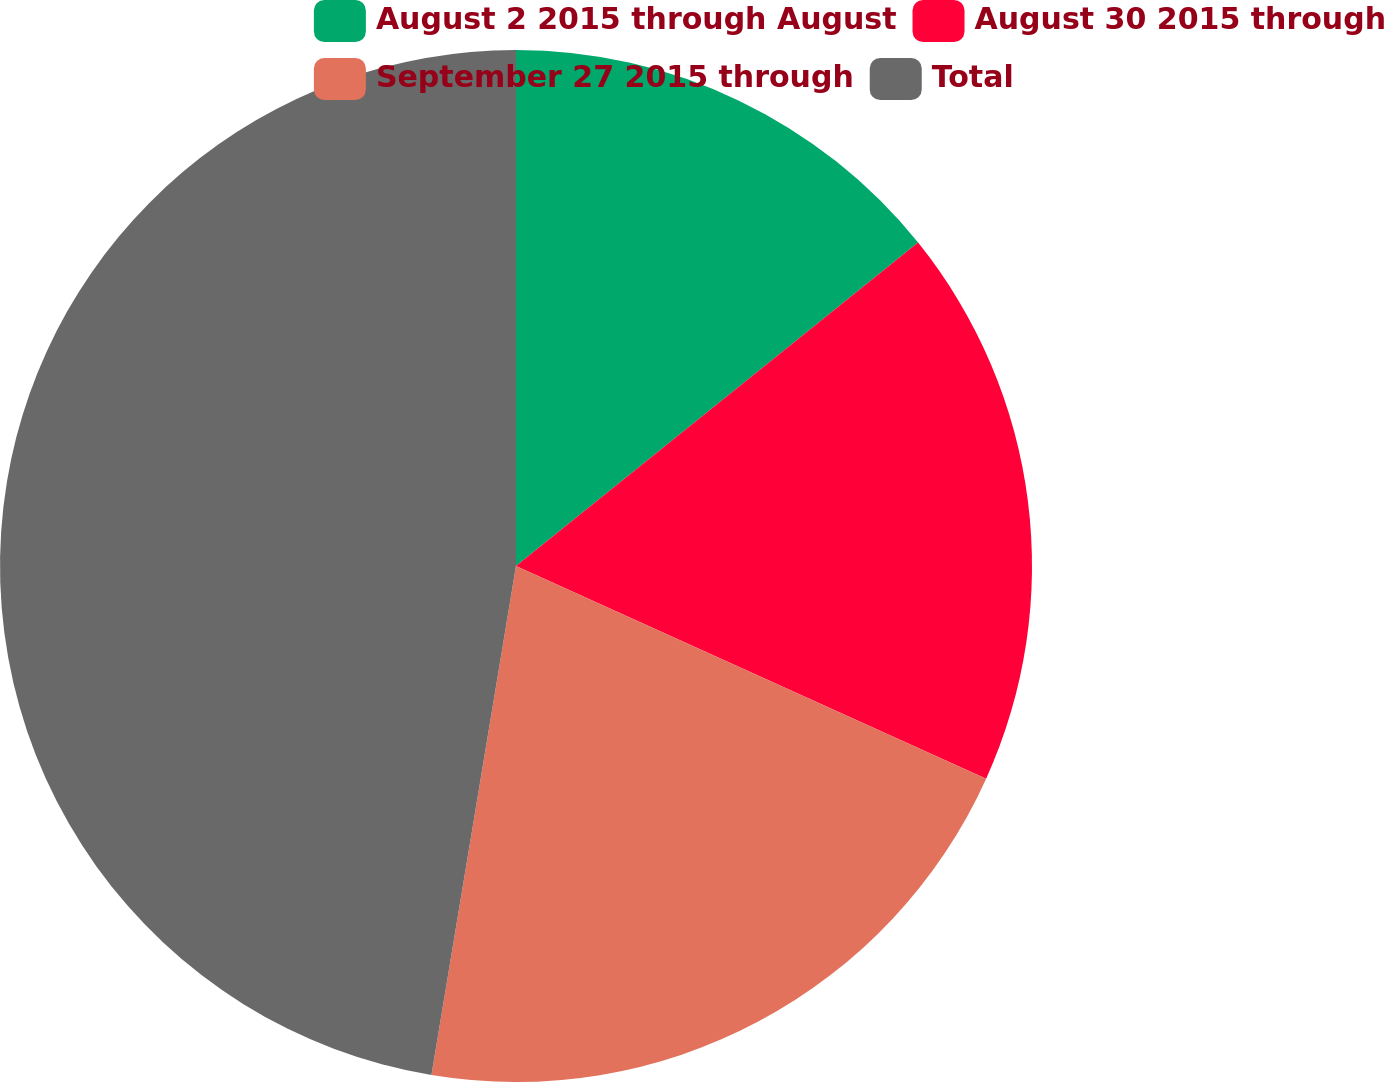Convert chart to OTSL. <chart><loc_0><loc_0><loc_500><loc_500><pie_chart><fcel>August 2 2015 through August<fcel>August 30 2015 through<fcel>September 27 2015 through<fcel>Total<nl><fcel>14.22%<fcel>17.54%<fcel>20.86%<fcel>47.38%<nl></chart> 